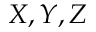Convert formula to latex. <formula><loc_0><loc_0><loc_500><loc_500>X , Y , Z</formula> 